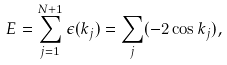Convert formula to latex. <formula><loc_0><loc_0><loc_500><loc_500>E = \sum _ { j = 1 } ^ { N + 1 } \epsilon ( k _ { j } ) = \sum _ { j } ( - 2 \cos k _ { j } ) ,</formula> 